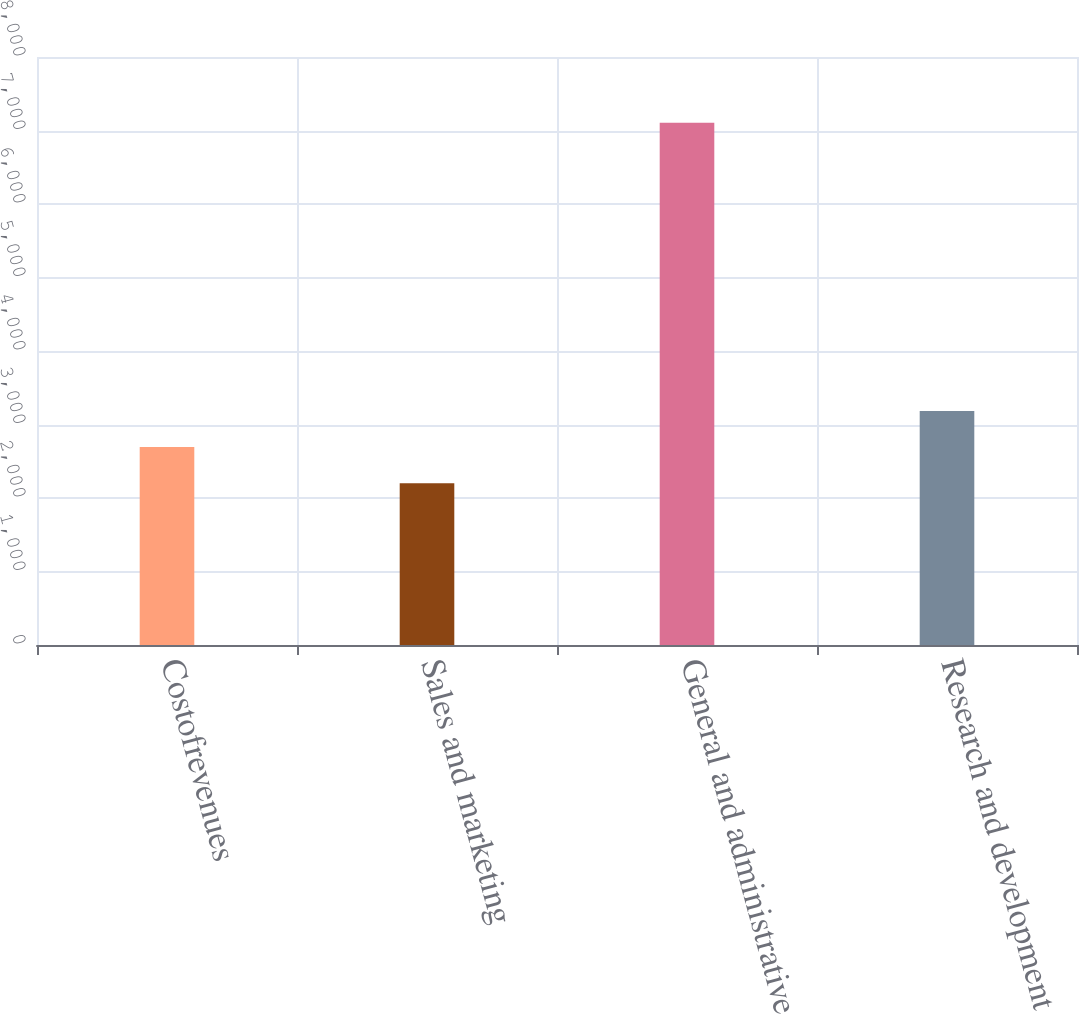Convert chart to OTSL. <chart><loc_0><loc_0><loc_500><loc_500><bar_chart><fcel>Costofrevenues<fcel>Sales and marketing<fcel>General and administrative<fcel>Research and development<nl><fcel>2692.5<fcel>2202<fcel>7107<fcel>3183<nl></chart> 